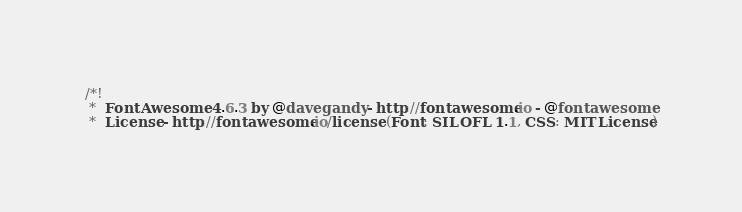<code> <loc_0><loc_0><loc_500><loc_500><_CSS_>/*!
 *  Font Awesome 4.6.3 by @davegandy - http://fontawesome.io - @fontawesome
 *  License - http://fontawesome.io/license (Font: SIL OFL 1.1, CSS: MIT License)</code> 